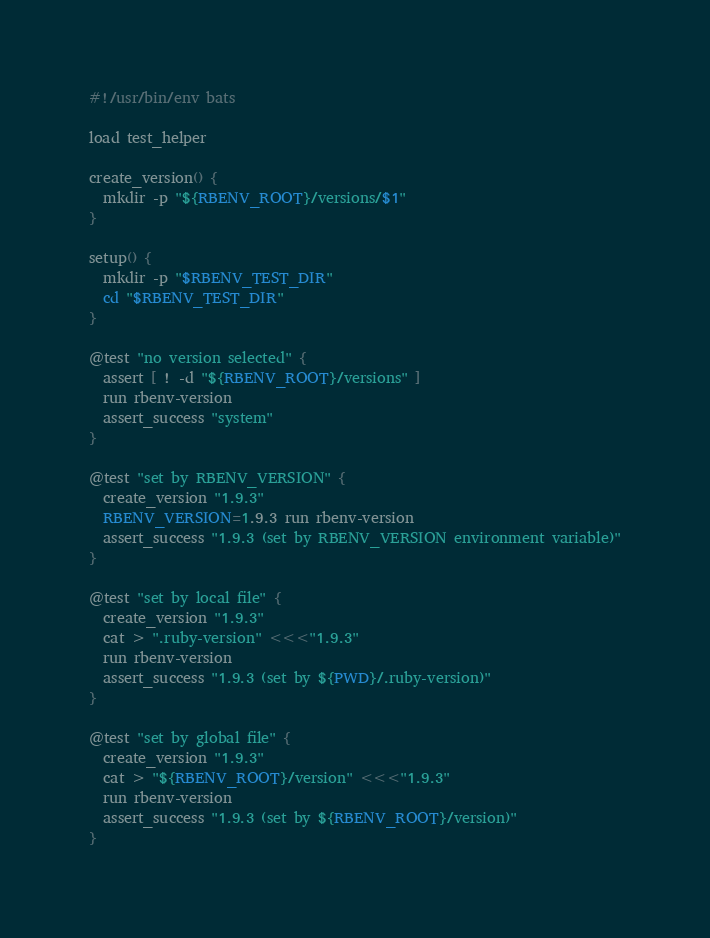Convert code to text. <code><loc_0><loc_0><loc_500><loc_500><_Bash_>#!/usr/bin/env bats

load test_helper

create_version() {
  mkdir -p "${RBENV_ROOT}/versions/$1"
}

setup() {
  mkdir -p "$RBENV_TEST_DIR"
  cd "$RBENV_TEST_DIR"
}

@test "no version selected" {
  assert [ ! -d "${RBENV_ROOT}/versions" ]
  run rbenv-version
  assert_success "system"
}

@test "set by RBENV_VERSION" {
  create_version "1.9.3"
  RBENV_VERSION=1.9.3 run rbenv-version
  assert_success "1.9.3 (set by RBENV_VERSION environment variable)"
}

@test "set by local file" {
  create_version "1.9.3"
  cat > ".ruby-version" <<<"1.9.3"
  run rbenv-version
  assert_success "1.9.3 (set by ${PWD}/.ruby-version)"
}

@test "set by global file" {
  create_version "1.9.3"
  cat > "${RBENV_ROOT}/version" <<<"1.9.3"
  run rbenv-version
  assert_success "1.9.3 (set by ${RBENV_ROOT}/version)"
}
</code> 